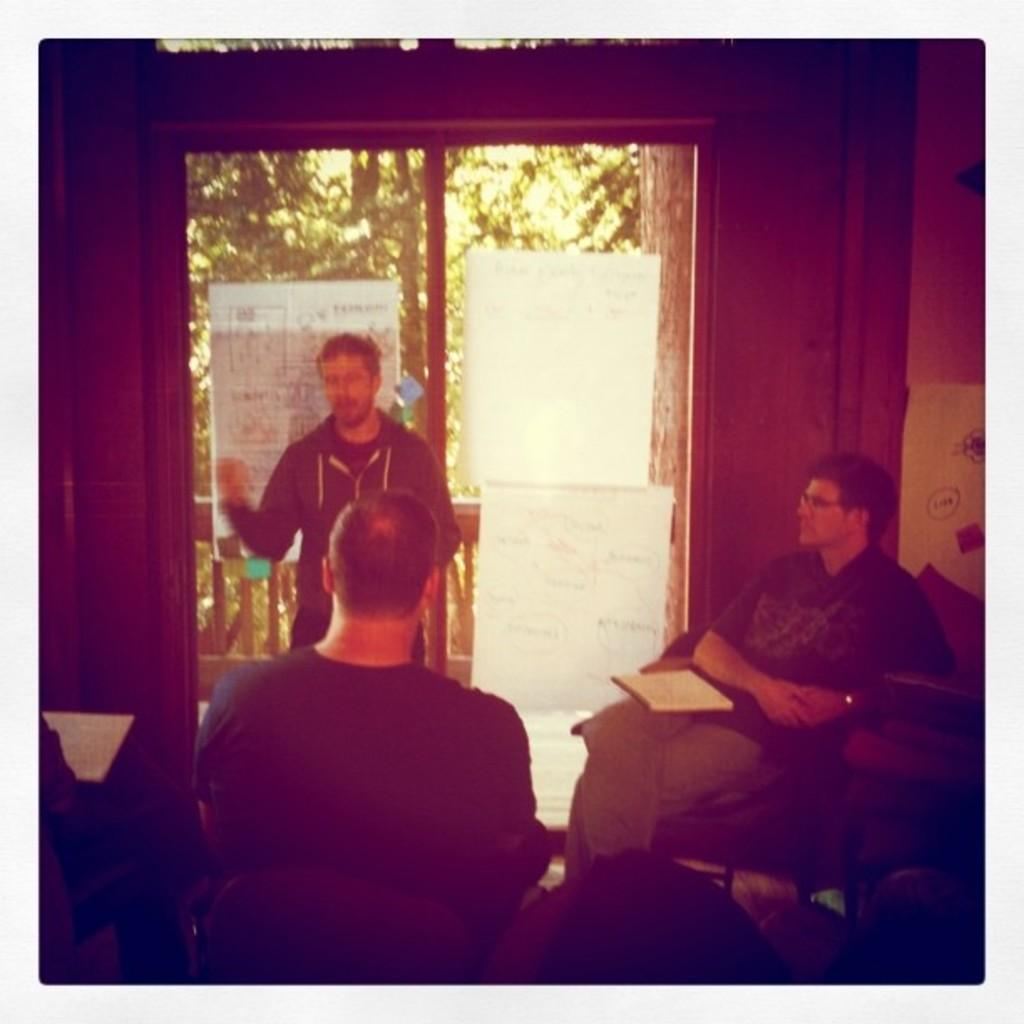How many people are sitting on the chair in the image? There are two persons sitting on a chair in the image. What is the man in the image doing? There is a man standing and talking in the image. What type of natural environment can be seen in the image? Trees are visible in the image. How many bikes are parked next to the cent in the image? There are no bikes or cent present in the image. What channel is the man watching on the television in the image? There is no television present in the image. 